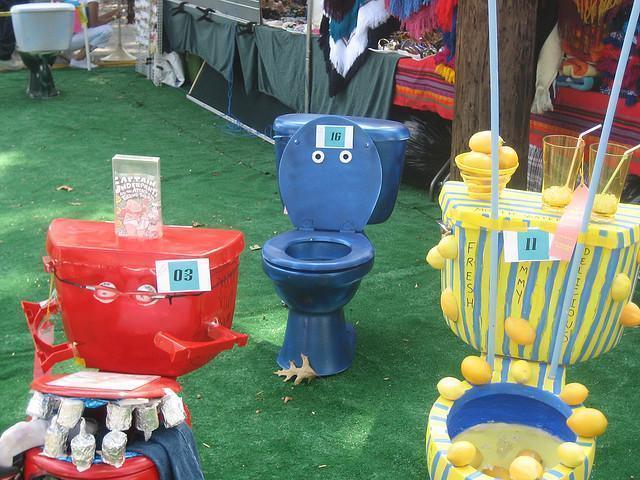The artistically displayed items here are normally connected to what?
From the following four choices, select the correct answer to address the question.
Options: Solar panels, roofs, electricity, plumbing. Plumbing. 